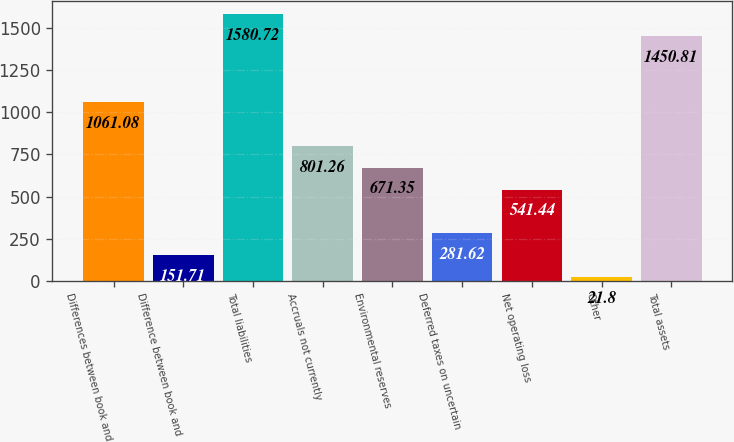Convert chart. <chart><loc_0><loc_0><loc_500><loc_500><bar_chart><fcel>Differences between book and<fcel>Difference between book and<fcel>Total liabilities<fcel>Accruals not currently<fcel>Environmental reserves<fcel>Deferred taxes on uncertain<fcel>Net operating loss<fcel>Other<fcel>Total assets<nl><fcel>1061.08<fcel>151.71<fcel>1580.72<fcel>801.26<fcel>671.35<fcel>281.62<fcel>541.44<fcel>21.8<fcel>1450.81<nl></chart> 